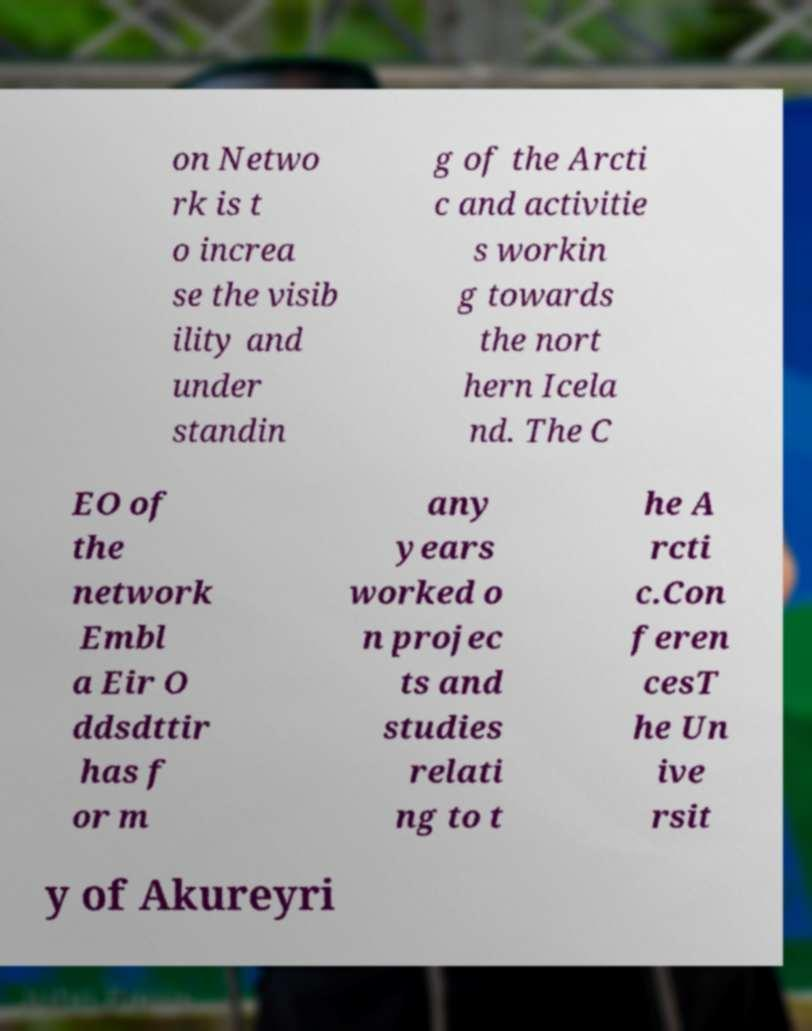What messages or text are displayed in this image? I need them in a readable, typed format. on Netwo rk is t o increa se the visib ility and under standin g of the Arcti c and activitie s workin g towards the nort hern Icela nd. The C EO of the network Embl a Eir O ddsdttir has f or m any years worked o n projec ts and studies relati ng to t he A rcti c.Con feren cesT he Un ive rsit y of Akureyri 